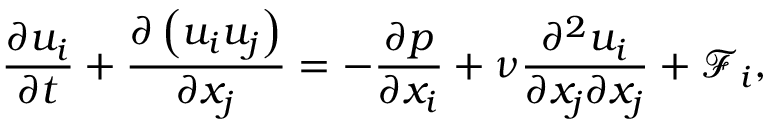Convert formula to latex. <formula><loc_0><loc_0><loc_500><loc_500>\frac { { \partial { u _ { i } } } } { \partial t } + \frac { { \partial \left ( { { u _ { i } } { u _ { j } } } \right ) } } { { \partial { x _ { j } } } } = - \frac { \partial p } { { \partial { x _ { i } } } } + \nu \frac { { { \partial ^ { 2 } } { u _ { i } } } } { { \partial { x _ { j } } \partial { x _ { j } } } } + { { \mathcal { F } } _ { i } } ,</formula> 